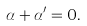Convert formula to latex. <formula><loc_0><loc_0><loc_500><loc_500>\alpha + \alpha ^ { \prime } = 0 .</formula> 